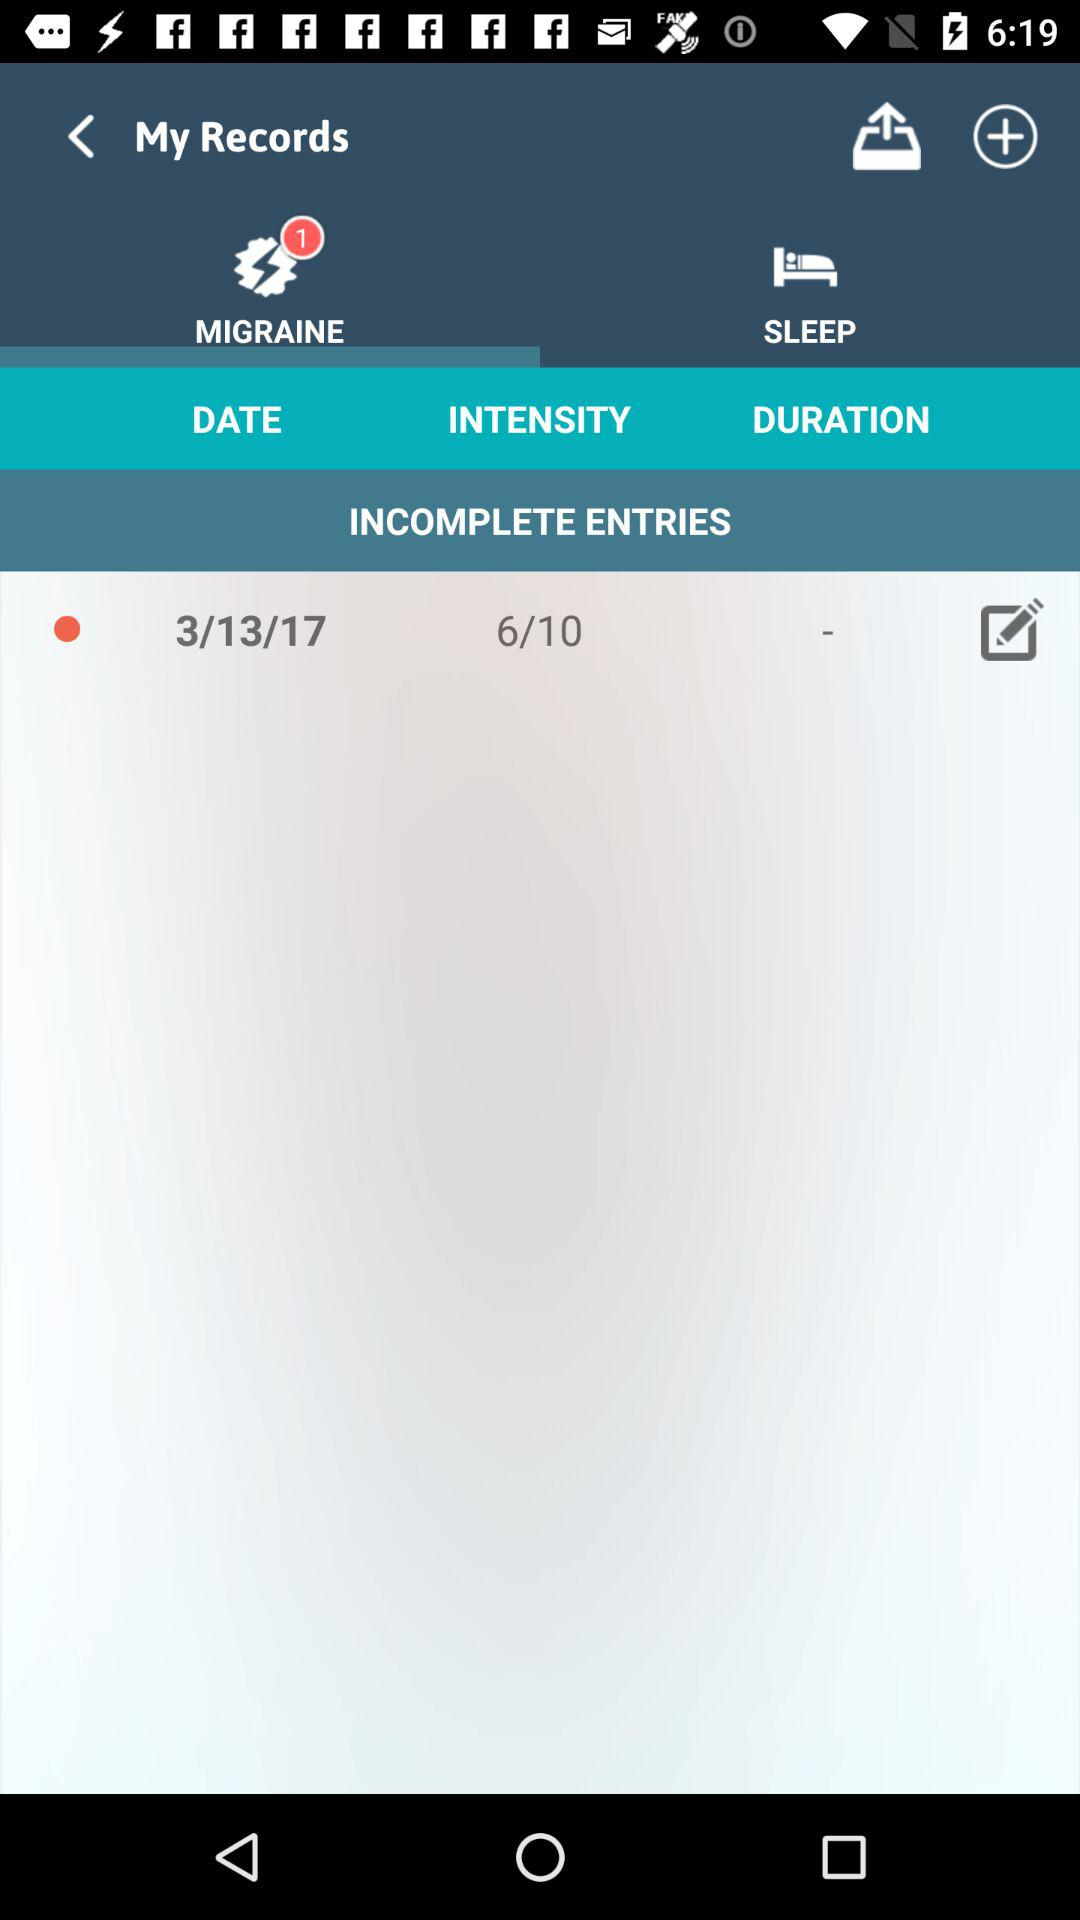How many notifications are unread in "MIGRANE"?
Answer the question using a single word or phrase. There is 1 unread notification in "MIGRANE" 